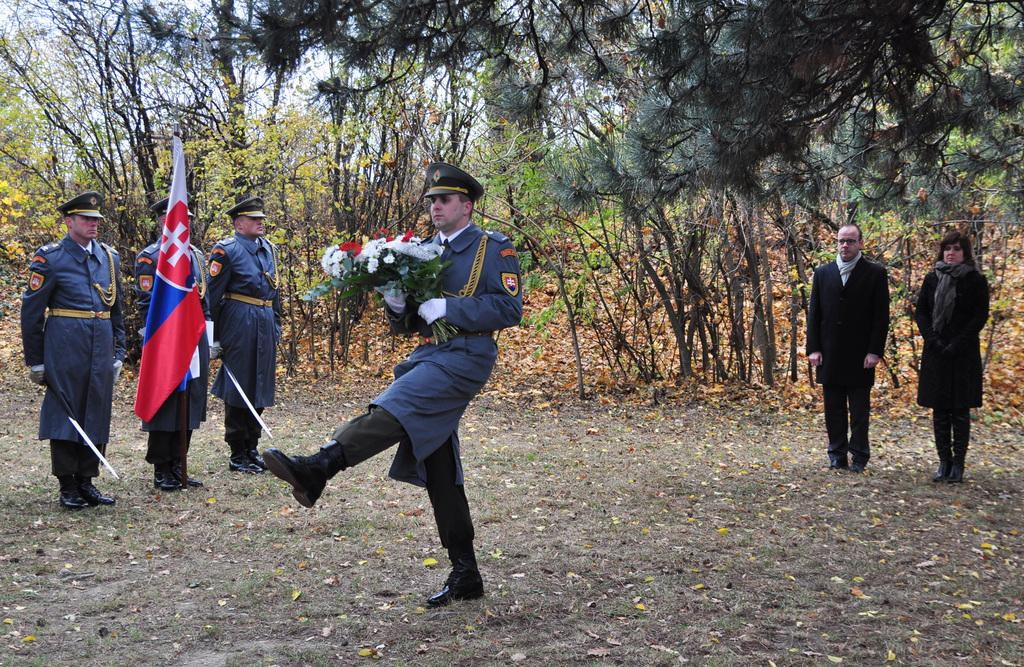What type of vegetation can be seen in the image? There is grass, leaves, trees, and flowers in the image. Are there any living beings present in the image? Yes, there are people in the image. What is the symbolic object visible in the image? There is a flag in the image. What part of the natural environment is visible in the image? The sky is visible in the image. What type of bean is being used as a doorstop in the image? There is no bean or doorstop present in the image. 